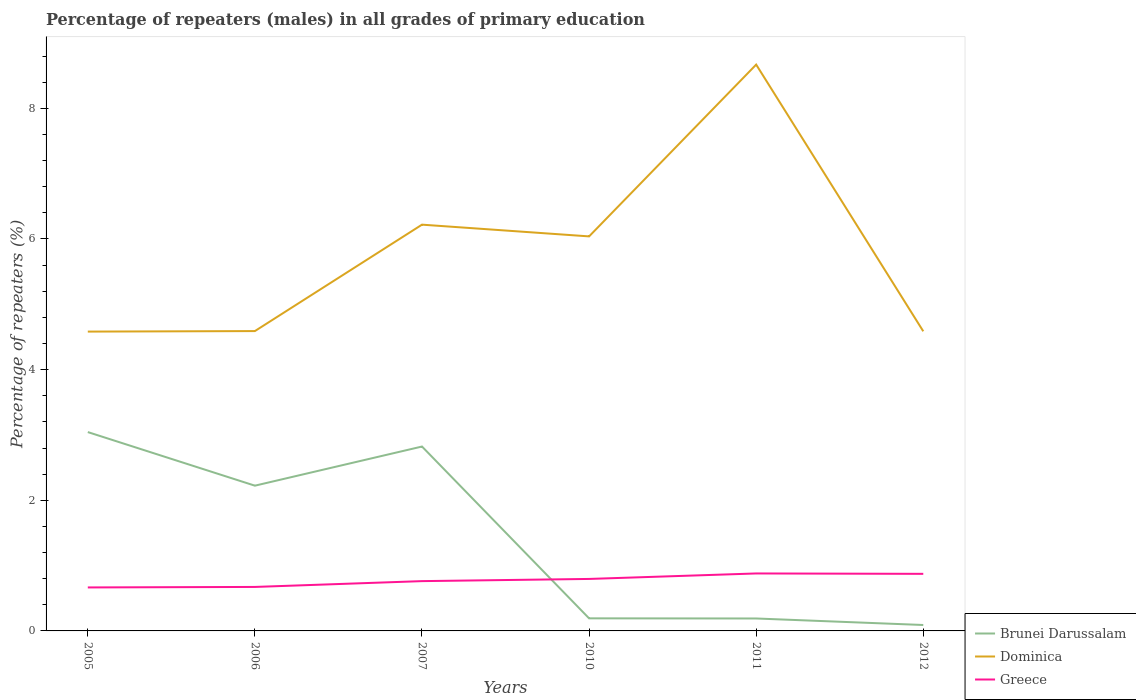Does the line corresponding to Dominica intersect with the line corresponding to Greece?
Ensure brevity in your answer.  No. Is the number of lines equal to the number of legend labels?
Ensure brevity in your answer.  Yes. Across all years, what is the maximum percentage of repeaters (males) in Greece?
Your answer should be compact. 0.67. In which year was the percentage of repeaters (males) in Greece maximum?
Offer a terse response. 2005. What is the total percentage of repeaters (males) in Dominica in the graph?
Your response must be concise. -4.09. What is the difference between the highest and the second highest percentage of repeaters (males) in Greece?
Your answer should be compact. 0.21. What is the difference between the highest and the lowest percentage of repeaters (males) in Greece?
Keep it short and to the point. 3. How many years are there in the graph?
Make the answer very short. 6. Does the graph contain any zero values?
Your answer should be very brief. No. Does the graph contain grids?
Your answer should be compact. No. Where does the legend appear in the graph?
Your answer should be very brief. Bottom right. How many legend labels are there?
Keep it short and to the point. 3. How are the legend labels stacked?
Make the answer very short. Vertical. What is the title of the graph?
Provide a short and direct response. Percentage of repeaters (males) in all grades of primary education. What is the label or title of the X-axis?
Give a very brief answer. Years. What is the label or title of the Y-axis?
Make the answer very short. Percentage of repeaters (%). What is the Percentage of repeaters (%) of Brunei Darussalam in 2005?
Your answer should be compact. 3.04. What is the Percentage of repeaters (%) in Dominica in 2005?
Keep it short and to the point. 4.58. What is the Percentage of repeaters (%) of Greece in 2005?
Ensure brevity in your answer.  0.67. What is the Percentage of repeaters (%) in Brunei Darussalam in 2006?
Your answer should be very brief. 2.22. What is the Percentage of repeaters (%) in Dominica in 2006?
Provide a succinct answer. 4.59. What is the Percentage of repeaters (%) of Greece in 2006?
Make the answer very short. 0.67. What is the Percentage of repeaters (%) in Brunei Darussalam in 2007?
Ensure brevity in your answer.  2.82. What is the Percentage of repeaters (%) of Dominica in 2007?
Your answer should be compact. 6.22. What is the Percentage of repeaters (%) of Greece in 2007?
Offer a terse response. 0.76. What is the Percentage of repeaters (%) in Brunei Darussalam in 2010?
Keep it short and to the point. 0.19. What is the Percentage of repeaters (%) of Dominica in 2010?
Provide a succinct answer. 6.04. What is the Percentage of repeaters (%) of Greece in 2010?
Provide a succinct answer. 0.8. What is the Percentage of repeaters (%) in Brunei Darussalam in 2011?
Keep it short and to the point. 0.19. What is the Percentage of repeaters (%) of Dominica in 2011?
Provide a succinct answer. 8.67. What is the Percentage of repeaters (%) in Greece in 2011?
Your answer should be compact. 0.88. What is the Percentage of repeaters (%) of Brunei Darussalam in 2012?
Your response must be concise. 0.09. What is the Percentage of repeaters (%) of Dominica in 2012?
Provide a succinct answer. 4.59. What is the Percentage of repeaters (%) in Greece in 2012?
Give a very brief answer. 0.87. Across all years, what is the maximum Percentage of repeaters (%) in Brunei Darussalam?
Your answer should be very brief. 3.04. Across all years, what is the maximum Percentage of repeaters (%) in Dominica?
Keep it short and to the point. 8.67. Across all years, what is the maximum Percentage of repeaters (%) in Greece?
Provide a succinct answer. 0.88. Across all years, what is the minimum Percentage of repeaters (%) of Brunei Darussalam?
Give a very brief answer. 0.09. Across all years, what is the minimum Percentage of repeaters (%) of Dominica?
Ensure brevity in your answer.  4.58. Across all years, what is the minimum Percentage of repeaters (%) in Greece?
Provide a succinct answer. 0.67. What is the total Percentage of repeaters (%) of Brunei Darussalam in the graph?
Your response must be concise. 8.56. What is the total Percentage of repeaters (%) of Dominica in the graph?
Give a very brief answer. 34.69. What is the total Percentage of repeaters (%) in Greece in the graph?
Make the answer very short. 4.65. What is the difference between the Percentage of repeaters (%) in Brunei Darussalam in 2005 and that in 2006?
Give a very brief answer. 0.82. What is the difference between the Percentage of repeaters (%) in Dominica in 2005 and that in 2006?
Your answer should be compact. -0.01. What is the difference between the Percentage of repeaters (%) in Greece in 2005 and that in 2006?
Provide a succinct answer. -0.01. What is the difference between the Percentage of repeaters (%) of Brunei Darussalam in 2005 and that in 2007?
Your answer should be compact. 0.22. What is the difference between the Percentage of repeaters (%) in Dominica in 2005 and that in 2007?
Provide a succinct answer. -1.64. What is the difference between the Percentage of repeaters (%) of Greece in 2005 and that in 2007?
Make the answer very short. -0.1. What is the difference between the Percentage of repeaters (%) in Brunei Darussalam in 2005 and that in 2010?
Your answer should be very brief. 2.85. What is the difference between the Percentage of repeaters (%) in Dominica in 2005 and that in 2010?
Provide a short and direct response. -1.46. What is the difference between the Percentage of repeaters (%) of Greece in 2005 and that in 2010?
Give a very brief answer. -0.13. What is the difference between the Percentage of repeaters (%) in Brunei Darussalam in 2005 and that in 2011?
Offer a terse response. 2.85. What is the difference between the Percentage of repeaters (%) of Dominica in 2005 and that in 2011?
Make the answer very short. -4.09. What is the difference between the Percentage of repeaters (%) in Greece in 2005 and that in 2011?
Provide a succinct answer. -0.21. What is the difference between the Percentage of repeaters (%) in Brunei Darussalam in 2005 and that in 2012?
Your answer should be very brief. 2.95. What is the difference between the Percentage of repeaters (%) in Dominica in 2005 and that in 2012?
Your response must be concise. -0. What is the difference between the Percentage of repeaters (%) of Greece in 2005 and that in 2012?
Provide a short and direct response. -0.21. What is the difference between the Percentage of repeaters (%) in Brunei Darussalam in 2006 and that in 2007?
Offer a terse response. -0.6. What is the difference between the Percentage of repeaters (%) of Dominica in 2006 and that in 2007?
Your answer should be compact. -1.63. What is the difference between the Percentage of repeaters (%) of Greece in 2006 and that in 2007?
Give a very brief answer. -0.09. What is the difference between the Percentage of repeaters (%) of Brunei Darussalam in 2006 and that in 2010?
Your answer should be very brief. 2.03. What is the difference between the Percentage of repeaters (%) of Dominica in 2006 and that in 2010?
Your answer should be compact. -1.45. What is the difference between the Percentage of repeaters (%) in Greece in 2006 and that in 2010?
Your answer should be compact. -0.12. What is the difference between the Percentage of repeaters (%) of Brunei Darussalam in 2006 and that in 2011?
Provide a short and direct response. 2.03. What is the difference between the Percentage of repeaters (%) in Dominica in 2006 and that in 2011?
Give a very brief answer. -4.08. What is the difference between the Percentage of repeaters (%) in Greece in 2006 and that in 2011?
Your answer should be compact. -0.21. What is the difference between the Percentage of repeaters (%) of Brunei Darussalam in 2006 and that in 2012?
Your answer should be compact. 2.13. What is the difference between the Percentage of repeaters (%) in Dominica in 2006 and that in 2012?
Your response must be concise. 0. What is the difference between the Percentage of repeaters (%) in Greece in 2006 and that in 2012?
Offer a terse response. -0.2. What is the difference between the Percentage of repeaters (%) of Brunei Darussalam in 2007 and that in 2010?
Keep it short and to the point. 2.63. What is the difference between the Percentage of repeaters (%) in Dominica in 2007 and that in 2010?
Provide a short and direct response. 0.18. What is the difference between the Percentage of repeaters (%) of Greece in 2007 and that in 2010?
Provide a succinct answer. -0.03. What is the difference between the Percentage of repeaters (%) in Brunei Darussalam in 2007 and that in 2011?
Give a very brief answer. 2.63. What is the difference between the Percentage of repeaters (%) of Dominica in 2007 and that in 2011?
Offer a very short reply. -2.45. What is the difference between the Percentage of repeaters (%) of Greece in 2007 and that in 2011?
Offer a terse response. -0.12. What is the difference between the Percentage of repeaters (%) of Brunei Darussalam in 2007 and that in 2012?
Your response must be concise. 2.73. What is the difference between the Percentage of repeaters (%) of Dominica in 2007 and that in 2012?
Keep it short and to the point. 1.63. What is the difference between the Percentage of repeaters (%) of Greece in 2007 and that in 2012?
Ensure brevity in your answer.  -0.11. What is the difference between the Percentage of repeaters (%) in Brunei Darussalam in 2010 and that in 2011?
Your answer should be very brief. 0. What is the difference between the Percentage of repeaters (%) of Dominica in 2010 and that in 2011?
Provide a succinct answer. -2.63. What is the difference between the Percentage of repeaters (%) of Greece in 2010 and that in 2011?
Make the answer very short. -0.08. What is the difference between the Percentage of repeaters (%) of Brunei Darussalam in 2010 and that in 2012?
Your response must be concise. 0.1. What is the difference between the Percentage of repeaters (%) of Dominica in 2010 and that in 2012?
Your answer should be very brief. 1.45. What is the difference between the Percentage of repeaters (%) in Greece in 2010 and that in 2012?
Your answer should be very brief. -0.08. What is the difference between the Percentage of repeaters (%) of Brunei Darussalam in 2011 and that in 2012?
Ensure brevity in your answer.  0.1. What is the difference between the Percentage of repeaters (%) in Dominica in 2011 and that in 2012?
Provide a short and direct response. 4.08. What is the difference between the Percentage of repeaters (%) in Greece in 2011 and that in 2012?
Provide a succinct answer. 0.01. What is the difference between the Percentage of repeaters (%) in Brunei Darussalam in 2005 and the Percentage of repeaters (%) in Dominica in 2006?
Make the answer very short. -1.55. What is the difference between the Percentage of repeaters (%) in Brunei Darussalam in 2005 and the Percentage of repeaters (%) in Greece in 2006?
Your answer should be compact. 2.37. What is the difference between the Percentage of repeaters (%) in Dominica in 2005 and the Percentage of repeaters (%) in Greece in 2006?
Your answer should be compact. 3.91. What is the difference between the Percentage of repeaters (%) in Brunei Darussalam in 2005 and the Percentage of repeaters (%) in Dominica in 2007?
Keep it short and to the point. -3.18. What is the difference between the Percentage of repeaters (%) in Brunei Darussalam in 2005 and the Percentage of repeaters (%) in Greece in 2007?
Offer a very short reply. 2.28. What is the difference between the Percentage of repeaters (%) of Dominica in 2005 and the Percentage of repeaters (%) of Greece in 2007?
Your answer should be compact. 3.82. What is the difference between the Percentage of repeaters (%) in Brunei Darussalam in 2005 and the Percentage of repeaters (%) in Dominica in 2010?
Provide a succinct answer. -3. What is the difference between the Percentage of repeaters (%) of Brunei Darussalam in 2005 and the Percentage of repeaters (%) of Greece in 2010?
Make the answer very short. 2.25. What is the difference between the Percentage of repeaters (%) in Dominica in 2005 and the Percentage of repeaters (%) in Greece in 2010?
Your response must be concise. 3.79. What is the difference between the Percentage of repeaters (%) in Brunei Darussalam in 2005 and the Percentage of repeaters (%) in Dominica in 2011?
Your answer should be very brief. -5.63. What is the difference between the Percentage of repeaters (%) in Brunei Darussalam in 2005 and the Percentage of repeaters (%) in Greece in 2011?
Offer a terse response. 2.16. What is the difference between the Percentage of repeaters (%) of Dominica in 2005 and the Percentage of repeaters (%) of Greece in 2011?
Provide a short and direct response. 3.7. What is the difference between the Percentage of repeaters (%) of Brunei Darussalam in 2005 and the Percentage of repeaters (%) of Dominica in 2012?
Keep it short and to the point. -1.54. What is the difference between the Percentage of repeaters (%) of Brunei Darussalam in 2005 and the Percentage of repeaters (%) of Greece in 2012?
Offer a very short reply. 2.17. What is the difference between the Percentage of repeaters (%) in Dominica in 2005 and the Percentage of repeaters (%) in Greece in 2012?
Make the answer very short. 3.71. What is the difference between the Percentage of repeaters (%) in Brunei Darussalam in 2006 and the Percentage of repeaters (%) in Dominica in 2007?
Keep it short and to the point. -4. What is the difference between the Percentage of repeaters (%) of Brunei Darussalam in 2006 and the Percentage of repeaters (%) of Greece in 2007?
Provide a short and direct response. 1.46. What is the difference between the Percentage of repeaters (%) of Dominica in 2006 and the Percentage of repeaters (%) of Greece in 2007?
Give a very brief answer. 3.83. What is the difference between the Percentage of repeaters (%) of Brunei Darussalam in 2006 and the Percentage of repeaters (%) of Dominica in 2010?
Your answer should be very brief. -3.82. What is the difference between the Percentage of repeaters (%) in Brunei Darussalam in 2006 and the Percentage of repeaters (%) in Greece in 2010?
Make the answer very short. 1.43. What is the difference between the Percentage of repeaters (%) in Dominica in 2006 and the Percentage of repeaters (%) in Greece in 2010?
Offer a very short reply. 3.79. What is the difference between the Percentage of repeaters (%) in Brunei Darussalam in 2006 and the Percentage of repeaters (%) in Dominica in 2011?
Your answer should be very brief. -6.45. What is the difference between the Percentage of repeaters (%) in Brunei Darussalam in 2006 and the Percentage of repeaters (%) in Greece in 2011?
Your answer should be very brief. 1.34. What is the difference between the Percentage of repeaters (%) in Dominica in 2006 and the Percentage of repeaters (%) in Greece in 2011?
Your response must be concise. 3.71. What is the difference between the Percentage of repeaters (%) of Brunei Darussalam in 2006 and the Percentage of repeaters (%) of Dominica in 2012?
Offer a very short reply. -2.36. What is the difference between the Percentage of repeaters (%) of Brunei Darussalam in 2006 and the Percentage of repeaters (%) of Greece in 2012?
Your answer should be very brief. 1.35. What is the difference between the Percentage of repeaters (%) in Dominica in 2006 and the Percentage of repeaters (%) in Greece in 2012?
Give a very brief answer. 3.72. What is the difference between the Percentage of repeaters (%) in Brunei Darussalam in 2007 and the Percentage of repeaters (%) in Dominica in 2010?
Your answer should be compact. -3.22. What is the difference between the Percentage of repeaters (%) of Brunei Darussalam in 2007 and the Percentage of repeaters (%) of Greece in 2010?
Your response must be concise. 2.03. What is the difference between the Percentage of repeaters (%) in Dominica in 2007 and the Percentage of repeaters (%) in Greece in 2010?
Keep it short and to the point. 5.42. What is the difference between the Percentage of repeaters (%) in Brunei Darussalam in 2007 and the Percentage of repeaters (%) in Dominica in 2011?
Provide a short and direct response. -5.85. What is the difference between the Percentage of repeaters (%) of Brunei Darussalam in 2007 and the Percentage of repeaters (%) of Greece in 2011?
Offer a very short reply. 1.94. What is the difference between the Percentage of repeaters (%) of Dominica in 2007 and the Percentage of repeaters (%) of Greece in 2011?
Make the answer very short. 5.34. What is the difference between the Percentage of repeaters (%) in Brunei Darussalam in 2007 and the Percentage of repeaters (%) in Dominica in 2012?
Provide a succinct answer. -1.76. What is the difference between the Percentage of repeaters (%) of Brunei Darussalam in 2007 and the Percentage of repeaters (%) of Greece in 2012?
Provide a short and direct response. 1.95. What is the difference between the Percentage of repeaters (%) of Dominica in 2007 and the Percentage of repeaters (%) of Greece in 2012?
Your answer should be very brief. 5.35. What is the difference between the Percentage of repeaters (%) in Brunei Darussalam in 2010 and the Percentage of repeaters (%) in Dominica in 2011?
Keep it short and to the point. -8.48. What is the difference between the Percentage of repeaters (%) of Brunei Darussalam in 2010 and the Percentage of repeaters (%) of Greece in 2011?
Your answer should be very brief. -0.69. What is the difference between the Percentage of repeaters (%) in Dominica in 2010 and the Percentage of repeaters (%) in Greece in 2011?
Offer a terse response. 5.16. What is the difference between the Percentage of repeaters (%) in Brunei Darussalam in 2010 and the Percentage of repeaters (%) in Dominica in 2012?
Ensure brevity in your answer.  -4.39. What is the difference between the Percentage of repeaters (%) in Brunei Darussalam in 2010 and the Percentage of repeaters (%) in Greece in 2012?
Ensure brevity in your answer.  -0.68. What is the difference between the Percentage of repeaters (%) in Dominica in 2010 and the Percentage of repeaters (%) in Greece in 2012?
Offer a terse response. 5.17. What is the difference between the Percentage of repeaters (%) in Brunei Darussalam in 2011 and the Percentage of repeaters (%) in Dominica in 2012?
Your answer should be very brief. -4.4. What is the difference between the Percentage of repeaters (%) of Brunei Darussalam in 2011 and the Percentage of repeaters (%) of Greece in 2012?
Your response must be concise. -0.68. What is the difference between the Percentage of repeaters (%) in Dominica in 2011 and the Percentage of repeaters (%) in Greece in 2012?
Your answer should be compact. 7.8. What is the average Percentage of repeaters (%) in Brunei Darussalam per year?
Your answer should be compact. 1.43. What is the average Percentage of repeaters (%) in Dominica per year?
Ensure brevity in your answer.  5.78. What is the average Percentage of repeaters (%) in Greece per year?
Offer a very short reply. 0.78. In the year 2005, what is the difference between the Percentage of repeaters (%) of Brunei Darussalam and Percentage of repeaters (%) of Dominica?
Your answer should be compact. -1.54. In the year 2005, what is the difference between the Percentage of repeaters (%) in Brunei Darussalam and Percentage of repeaters (%) in Greece?
Provide a succinct answer. 2.38. In the year 2005, what is the difference between the Percentage of repeaters (%) in Dominica and Percentage of repeaters (%) in Greece?
Provide a succinct answer. 3.92. In the year 2006, what is the difference between the Percentage of repeaters (%) in Brunei Darussalam and Percentage of repeaters (%) in Dominica?
Provide a succinct answer. -2.37. In the year 2006, what is the difference between the Percentage of repeaters (%) in Brunei Darussalam and Percentage of repeaters (%) in Greece?
Provide a succinct answer. 1.55. In the year 2006, what is the difference between the Percentage of repeaters (%) in Dominica and Percentage of repeaters (%) in Greece?
Offer a very short reply. 3.92. In the year 2007, what is the difference between the Percentage of repeaters (%) in Brunei Darussalam and Percentage of repeaters (%) in Dominica?
Give a very brief answer. -3.4. In the year 2007, what is the difference between the Percentage of repeaters (%) of Brunei Darussalam and Percentage of repeaters (%) of Greece?
Provide a short and direct response. 2.06. In the year 2007, what is the difference between the Percentage of repeaters (%) in Dominica and Percentage of repeaters (%) in Greece?
Provide a succinct answer. 5.46. In the year 2010, what is the difference between the Percentage of repeaters (%) in Brunei Darussalam and Percentage of repeaters (%) in Dominica?
Your response must be concise. -5.85. In the year 2010, what is the difference between the Percentage of repeaters (%) in Brunei Darussalam and Percentage of repeaters (%) in Greece?
Give a very brief answer. -0.6. In the year 2010, what is the difference between the Percentage of repeaters (%) of Dominica and Percentage of repeaters (%) of Greece?
Your response must be concise. 5.24. In the year 2011, what is the difference between the Percentage of repeaters (%) of Brunei Darussalam and Percentage of repeaters (%) of Dominica?
Provide a succinct answer. -8.48. In the year 2011, what is the difference between the Percentage of repeaters (%) of Brunei Darussalam and Percentage of repeaters (%) of Greece?
Provide a succinct answer. -0.69. In the year 2011, what is the difference between the Percentage of repeaters (%) of Dominica and Percentage of repeaters (%) of Greece?
Give a very brief answer. 7.79. In the year 2012, what is the difference between the Percentage of repeaters (%) of Brunei Darussalam and Percentage of repeaters (%) of Dominica?
Offer a very short reply. -4.5. In the year 2012, what is the difference between the Percentage of repeaters (%) of Brunei Darussalam and Percentage of repeaters (%) of Greece?
Provide a succinct answer. -0.78. In the year 2012, what is the difference between the Percentage of repeaters (%) in Dominica and Percentage of repeaters (%) in Greece?
Keep it short and to the point. 3.71. What is the ratio of the Percentage of repeaters (%) of Brunei Darussalam in 2005 to that in 2006?
Your response must be concise. 1.37. What is the ratio of the Percentage of repeaters (%) of Dominica in 2005 to that in 2006?
Provide a succinct answer. 1. What is the ratio of the Percentage of repeaters (%) of Greece in 2005 to that in 2006?
Offer a very short reply. 0.99. What is the ratio of the Percentage of repeaters (%) of Brunei Darussalam in 2005 to that in 2007?
Ensure brevity in your answer.  1.08. What is the ratio of the Percentage of repeaters (%) of Dominica in 2005 to that in 2007?
Make the answer very short. 0.74. What is the ratio of the Percentage of repeaters (%) in Greece in 2005 to that in 2007?
Your answer should be compact. 0.87. What is the ratio of the Percentage of repeaters (%) of Brunei Darussalam in 2005 to that in 2010?
Make the answer very short. 15.81. What is the ratio of the Percentage of repeaters (%) of Dominica in 2005 to that in 2010?
Give a very brief answer. 0.76. What is the ratio of the Percentage of repeaters (%) of Greece in 2005 to that in 2010?
Your response must be concise. 0.84. What is the ratio of the Percentage of repeaters (%) in Brunei Darussalam in 2005 to that in 2011?
Ensure brevity in your answer.  15.99. What is the ratio of the Percentage of repeaters (%) in Dominica in 2005 to that in 2011?
Offer a terse response. 0.53. What is the ratio of the Percentage of repeaters (%) in Greece in 2005 to that in 2011?
Give a very brief answer. 0.76. What is the ratio of the Percentage of repeaters (%) in Brunei Darussalam in 2005 to that in 2012?
Provide a succinct answer. 33.58. What is the ratio of the Percentage of repeaters (%) of Greece in 2005 to that in 2012?
Give a very brief answer. 0.76. What is the ratio of the Percentage of repeaters (%) in Brunei Darussalam in 2006 to that in 2007?
Offer a terse response. 0.79. What is the ratio of the Percentage of repeaters (%) of Dominica in 2006 to that in 2007?
Ensure brevity in your answer.  0.74. What is the ratio of the Percentage of repeaters (%) of Greece in 2006 to that in 2007?
Provide a succinct answer. 0.88. What is the ratio of the Percentage of repeaters (%) in Brunei Darussalam in 2006 to that in 2010?
Provide a short and direct response. 11.55. What is the ratio of the Percentage of repeaters (%) in Dominica in 2006 to that in 2010?
Offer a very short reply. 0.76. What is the ratio of the Percentage of repeaters (%) of Greece in 2006 to that in 2010?
Make the answer very short. 0.85. What is the ratio of the Percentage of repeaters (%) of Brunei Darussalam in 2006 to that in 2011?
Provide a short and direct response. 11.68. What is the ratio of the Percentage of repeaters (%) in Dominica in 2006 to that in 2011?
Provide a succinct answer. 0.53. What is the ratio of the Percentage of repeaters (%) of Greece in 2006 to that in 2011?
Provide a short and direct response. 0.77. What is the ratio of the Percentage of repeaters (%) of Brunei Darussalam in 2006 to that in 2012?
Give a very brief answer. 24.53. What is the ratio of the Percentage of repeaters (%) in Greece in 2006 to that in 2012?
Give a very brief answer. 0.77. What is the ratio of the Percentage of repeaters (%) of Brunei Darussalam in 2007 to that in 2010?
Your answer should be very brief. 14.66. What is the ratio of the Percentage of repeaters (%) in Dominica in 2007 to that in 2010?
Offer a terse response. 1.03. What is the ratio of the Percentage of repeaters (%) in Greece in 2007 to that in 2010?
Offer a very short reply. 0.96. What is the ratio of the Percentage of repeaters (%) of Brunei Darussalam in 2007 to that in 2011?
Offer a very short reply. 14.83. What is the ratio of the Percentage of repeaters (%) in Dominica in 2007 to that in 2011?
Offer a very short reply. 0.72. What is the ratio of the Percentage of repeaters (%) of Greece in 2007 to that in 2011?
Your answer should be compact. 0.87. What is the ratio of the Percentage of repeaters (%) in Brunei Darussalam in 2007 to that in 2012?
Provide a short and direct response. 31.14. What is the ratio of the Percentage of repeaters (%) of Dominica in 2007 to that in 2012?
Provide a succinct answer. 1.36. What is the ratio of the Percentage of repeaters (%) in Greece in 2007 to that in 2012?
Offer a very short reply. 0.87. What is the ratio of the Percentage of repeaters (%) of Brunei Darussalam in 2010 to that in 2011?
Offer a very short reply. 1.01. What is the ratio of the Percentage of repeaters (%) in Dominica in 2010 to that in 2011?
Provide a short and direct response. 0.7. What is the ratio of the Percentage of repeaters (%) in Greece in 2010 to that in 2011?
Your answer should be compact. 0.9. What is the ratio of the Percentage of repeaters (%) of Brunei Darussalam in 2010 to that in 2012?
Your answer should be very brief. 2.12. What is the ratio of the Percentage of repeaters (%) of Dominica in 2010 to that in 2012?
Provide a short and direct response. 1.32. What is the ratio of the Percentage of repeaters (%) of Greece in 2010 to that in 2012?
Provide a short and direct response. 0.91. What is the ratio of the Percentage of repeaters (%) of Brunei Darussalam in 2011 to that in 2012?
Give a very brief answer. 2.1. What is the ratio of the Percentage of repeaters (%) of Dominica in 2011 to that in 2012?
Your answer should be compact. 1.89. What is the ratio of the Percentage of repeaters (%) of Greece in 2011 to that in 2012?
Provide a short and direct response. 1.01. What is the difference between the highest and the second highest Percentage of repeaters (%) of Brunei Darussalam?
Offer a very short reply. 0.22. What is the difference between the highest and the second highest Percentage of repeaters (%) in Dominica?
Make the answer very short. 2.45. What is the difference between the highest and the second highest Percentage of repeaters (%) in Greece?
Offer a terse response. 0.01. What is the difference between the highest and the lowest Percentage of repeaters (%) in Brunei Darussalam?
Give a very brief answer. 2.95. What is the difference between the highest and the lowest Percentage of repeaters (%) in Dominica?
Ensure brevity in your answer.  4.09. What is the difference between the highest and the lowest Percentage of repeaters (%) in Greece?
Offer a very short reply. 0.21. 